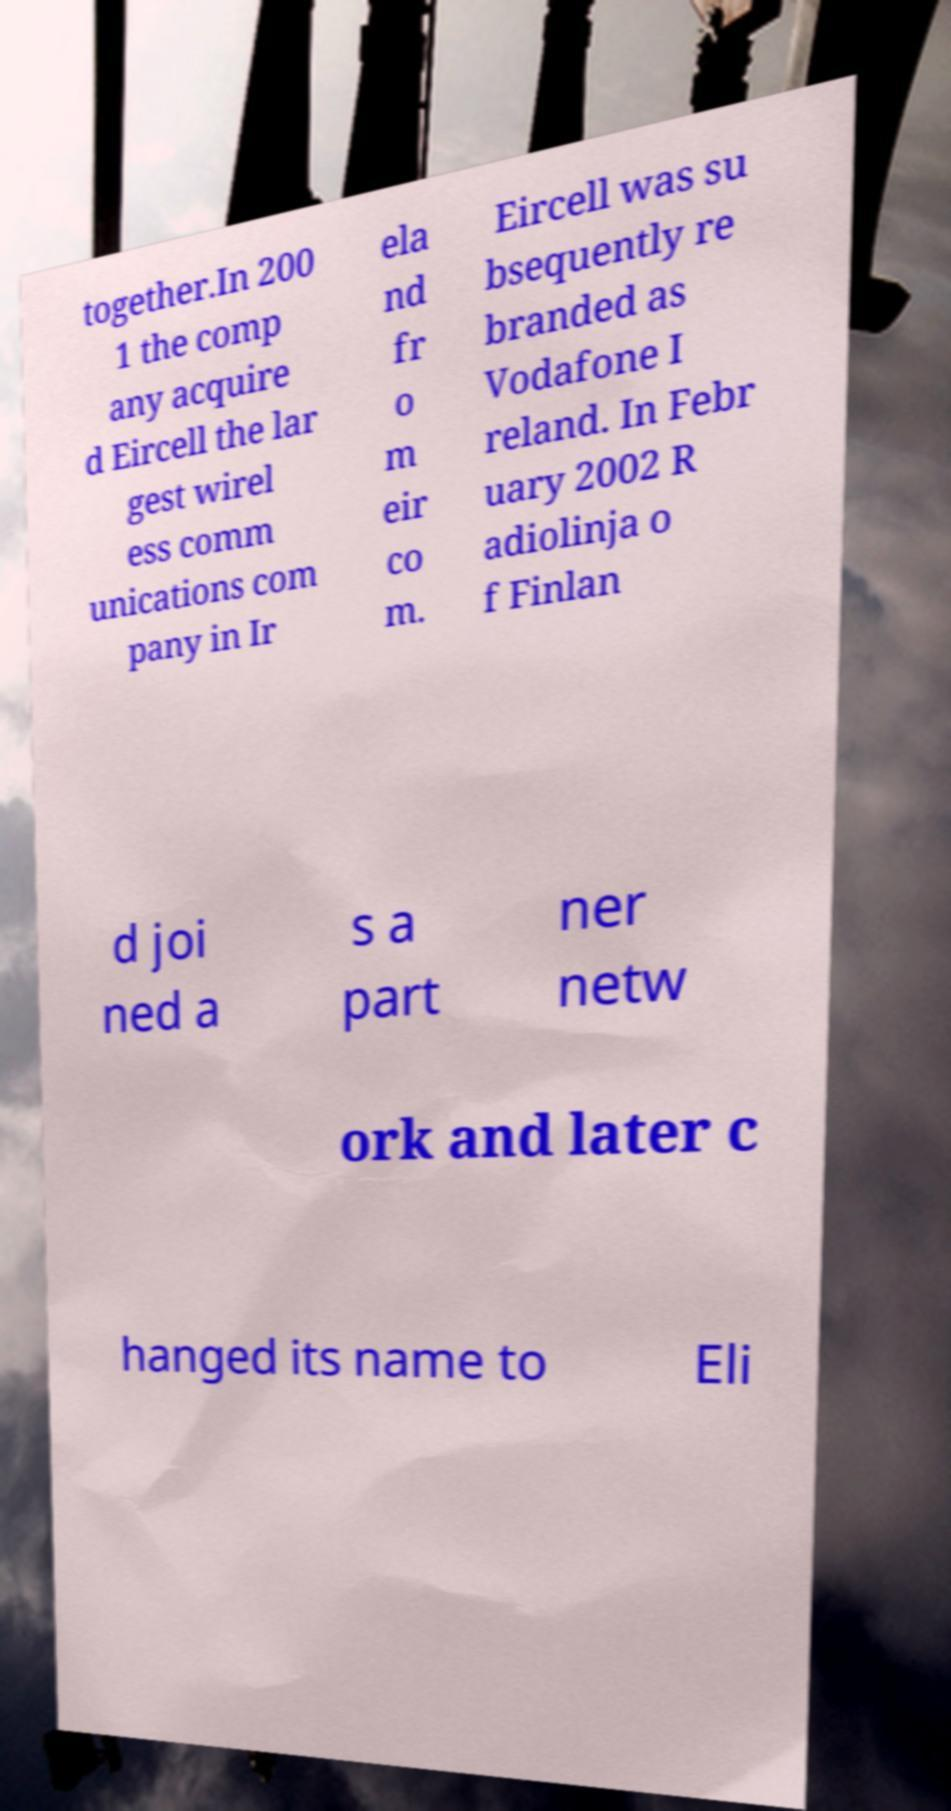Can you accurately transcribe the text from the provided image for me? together.In 200 1 the comp any acquire d Eircell the lar gest wirel ess comm unications com pany in Ir ela nd fr o m eir co m. Eircell was su bsequently re branded as Vodafone I reland. In Febr uary 2002 R adiolinja o f Finlan d joi ned a s a part ner netw ork and later c hanged its name to Eli 